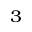Convert formula to latex. <formula><loc_0><loc_0><loc_500><loc_500>_ { 3 }</formula> 